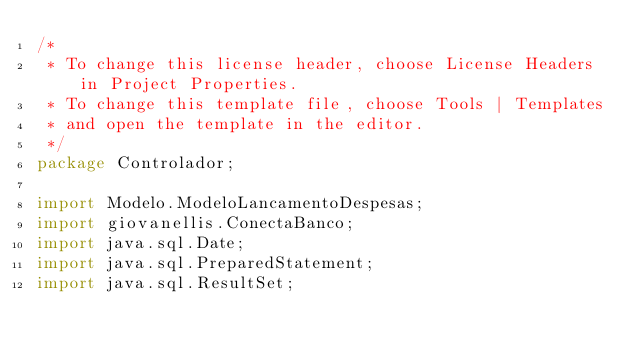<code> <loc_0><loc_0><loc_500><loc_500><_Java_>/*
 * To change this license header, choose License Headers in Project Properties.
 * To change this template file, choose Tools | Templates
 * and open the template in the editor.
 */
package Controlador;

import Modelo.ModeloLancamentoDespesas;
import giovanellis.ConectaBanco;
import java.sql.Date;
import java.sql.PreparedStatement;
import java.sql.ResultSet;</code> 